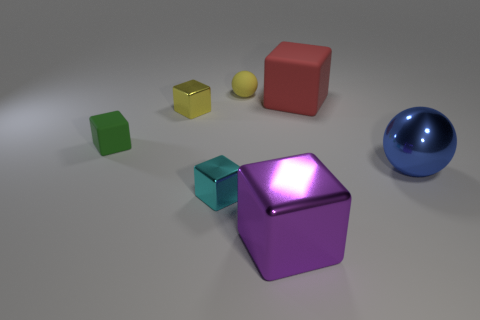Subtract all big blocks. How many blocks are left? 3 Subtract all red blocks. How many blocks are left? 4 Add 2 small shiny objects. How many objects exist? 9 Subtract all purple cubes. Subtract all cyan cylinders. How many cubes are left? 4 Subtract all cubes. How many objects are left? 2 Add 1 small yellow things. How many small yellow things are left? 3 Add 1 purple metal objects. How many purple metal objects exist? 2 Subtract 1 cyan cubes. How many objects are left? 6 Subtract all large red rubber blocks. Subtract all red things. How many objects are left? 5 